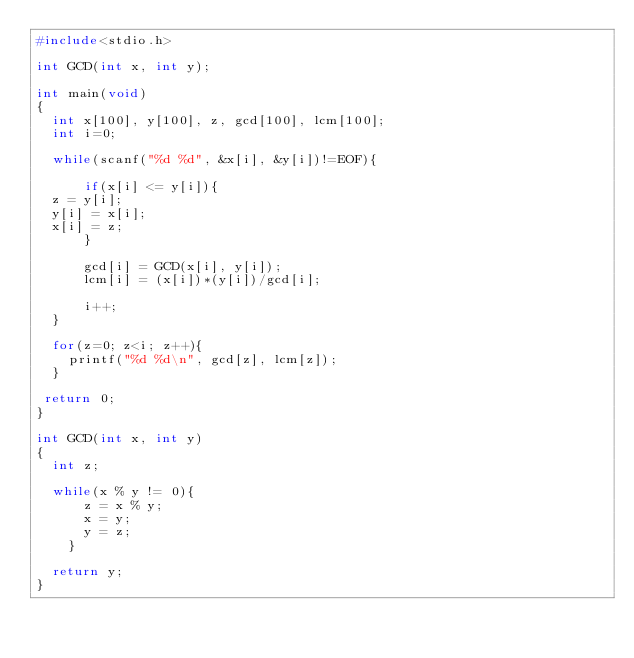<code> <loc_0><loc_0><loc_500><loc_500><_C_>#include<stdio.h>

int GCD(int x, int y);

int main(void)
{
  int x[100], y[100], z, gcd[100], lcm[100];
  int i=0;

  while(scanf("%d %d", &x[i], &y[i])!=EOF){

      if(x[i] <= y[i]){
	z = y[i];
	y[i] = x[i];
	x[i] = z;
      }
      
      gcd[i] = GCD(x[i], y[i]);
      lcm[i] = (x[i])*(y[i])/gcd[i];

      i++;   
  }
    
  for(z=0; z<i; z++){
    printf("%d %d\n", gcd[z], lcm[z]);
  } 
   
 return 0;
}

int GCD(int x, int y)
{
  int z;
  
  while(x % y != 0){
      z = x % y;
      x = y;
      y = z;
    }

  return y;
}</code> 